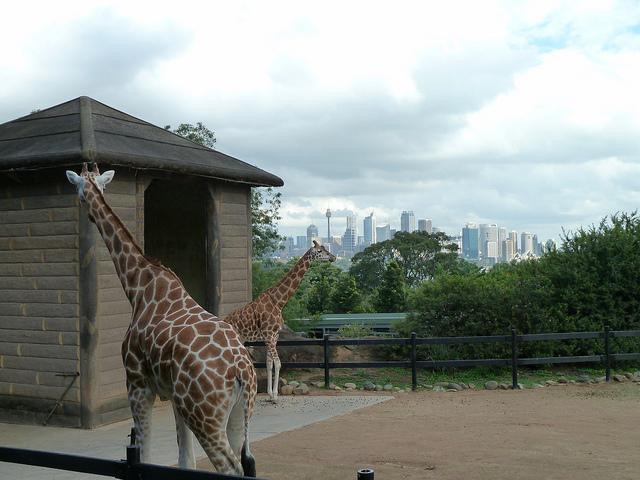How many giraffes are facing the camera?
Give a very brief answer. 0. How many giraffes are there?
Give a very brief answer. 2. How many giraffes can you see?
Give a very brief answer. 2. How many people are using a phone in the image?
Give a very brief answer. 0. 